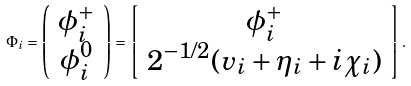Convert formula to latex. <formula><loc_0><loc_0><loc_500><loc_500>\Phi _ { i } = \left ( \begin{array} { c } { { \phi _ { i } ^ { + } } } \\ { { \phi _ { i } ^ { 0 } } } \end{array} \right ) = \left [ \begin{array} { c } { { \phi _ { i } ^ { + } } } \\ { { 2 ^ { - 1 / 2 } ( v _ { i } + \eta _ { i } + i \chi _ { i } ) } } \end{array} \right ] .</formula> 